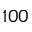Convert formula to latex. <formula><loc_0><loc_0><loc_500><loc_500>1 0 0</formula> 